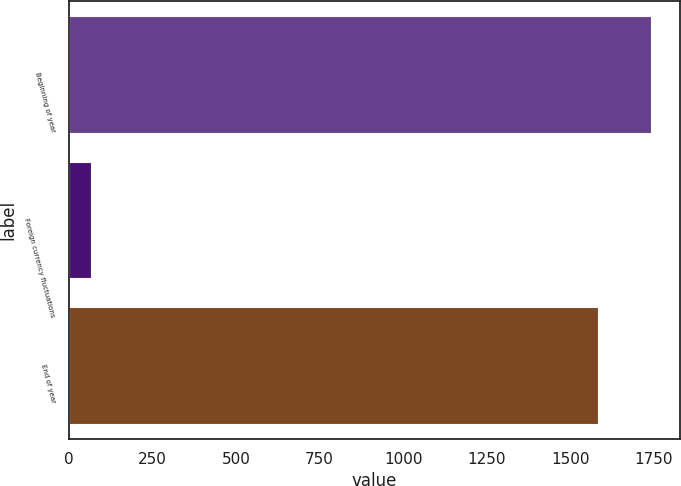Convert chart to OTSL. <chart><loc_0><loc_0><loc_500><loc_500><bar_chart><fcel>Beginning of year<fcel>Foreign currency fluctuations<fcel>End of year<nl><fcel>1739.82<fcel>67.5<fcel>1581.1<nl></chart> 